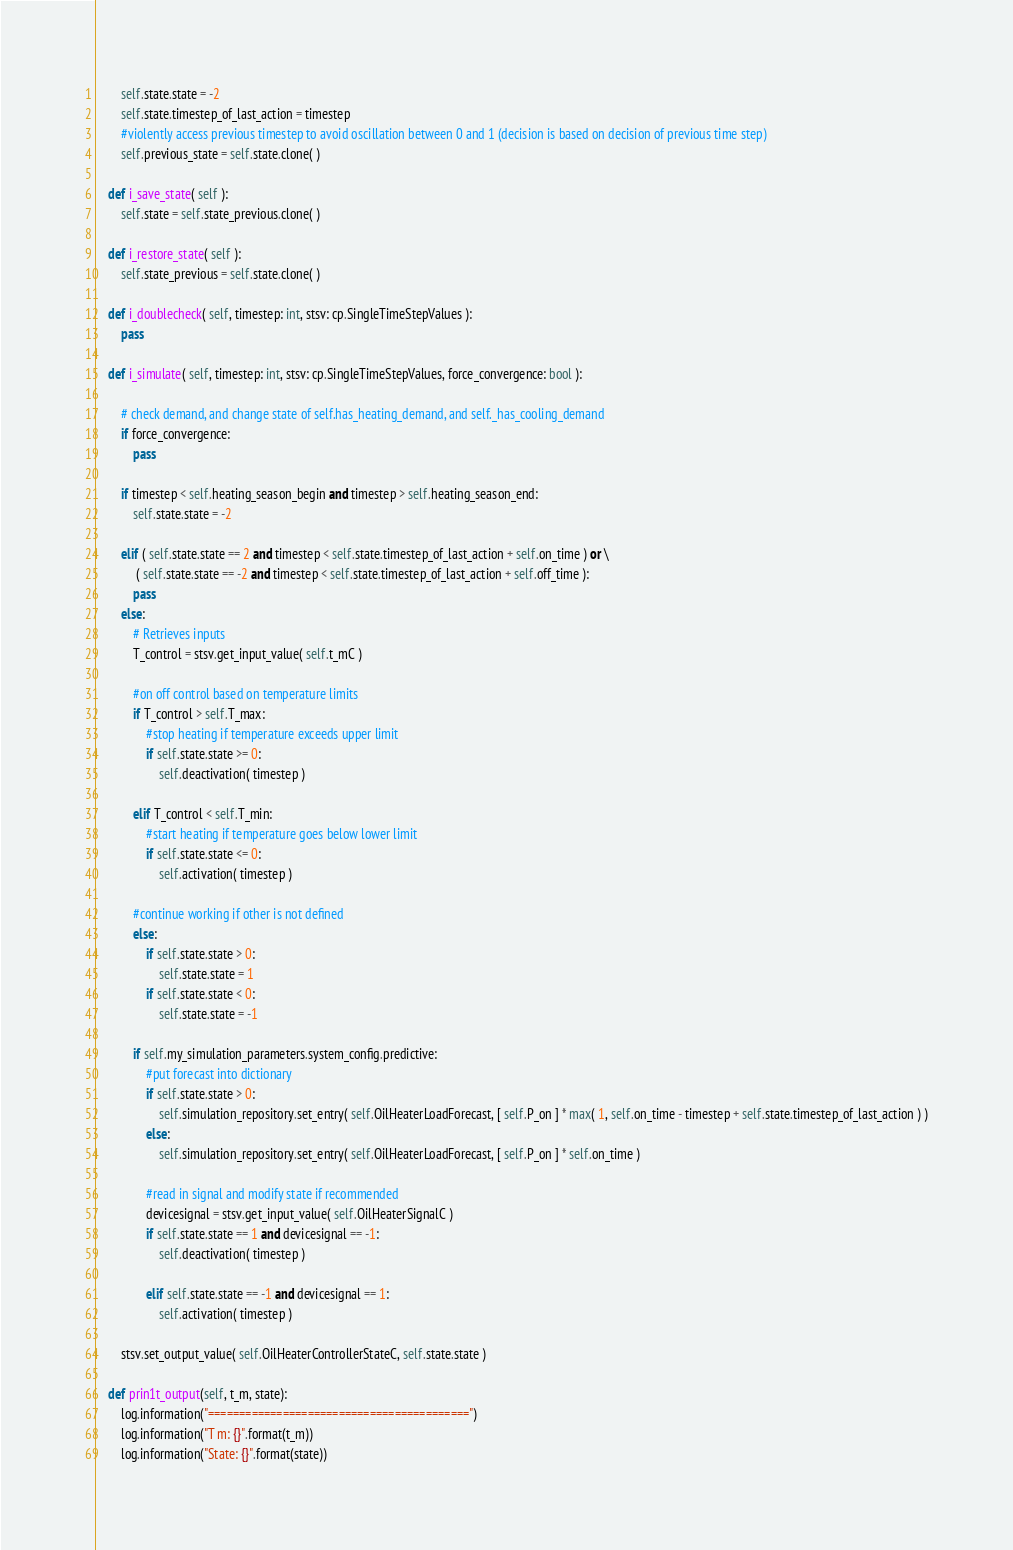Convert code to text. <code><loc_0><loc_0><loc_500><loc_500><_Python_>        self.state.state = -2
        self.state.timestep_of_last_action = timestep 
        #violently access previous timestep to avoid oscillation between 0 and 1 (decision is based on decision of previous time step)
        self.previous_state = self.state.clone( )

    def i_save_state( self ):
        self.state = self.state_previous.clone( )

    def i_restore_state( self ):
        self.state_previous = self.state.clone( )

    def i_doublecheck( self, timestep: int, stsv: cp.SingleTimeStepValues ):
        pass

    def i_simulate( self, timestep: int, stsv: cp.SingleTimeStepValues, force_convergence: bool ):
        
        # check demand, and change state of self.has_heating_demand, and self._has_cooling_demand
        if force_convergence:
            pass
        
        if timestep < self.heating_season_begin and timestep > self.heating_season_end:
            self.state.state = -2
            
        elif ( self.state.state == 2 and timestep < self.state.timestep_of_last_action + self.on_time ) or \
             ( self.state.state == -2 and timestep < self.state.timestep_of_last_action + self.off_time ):
            pass
        else:
            # Retrieves inputs
            T_control = stsv.get_input_value( self.t_mC )
    
            #on off control based on temperature limits
            if T_control > self.T_max:
                #stop heating if temperature exceeds upper limit
                if self.state.state >= 0:
                    self.deactivation( timestep )

            elif T_control < self.T_min:
                #start heating if temperature goes below lower limit
                if self.state.state <= 0:
                    self.activation( timestep )
             
            #continue working if other is not defined    
            else:
                if self.state.state > 0:
                    self.state.state = 1
                if self.state.state < 0:
                    self.state.state = -1
        
            if self.my_simulation_parameters.system_config.predictive:
                #put forecast into dictionary
                if self.state.state > 0:
                    self.simulation_repository.set_entry( self.OilHeaterLoadForecast, [ self.P_on ] * max( 1, self.on_time - timestep + self.state.timestep_of_last_action ) )
                else:
                    self.simulation_repository.set_entry( self.OilHeaterLoadForecast, [ self.P_on ] * self.on_time )
                    
                #read in signal and modify state if recommended
                devicesignal = stsv.get_input_value( self.OilHeaterSignalC )
                if self.state.state == 1 and devicesignal == -1:
                    self.deactivation( timestep )
                    
                elif self.state.state == -1 and devicesignal == 1:
                    self.activation( timestep )
        
        stsv.set_output_value( self.OilHeaterControllerStateC, self.state.state )

    def prin1t_output(self, t_m, state):
        log.information("==========================================")
        log.information("T m: {}".format(t_m))
        log.information("State: {}".format(state))</code> 